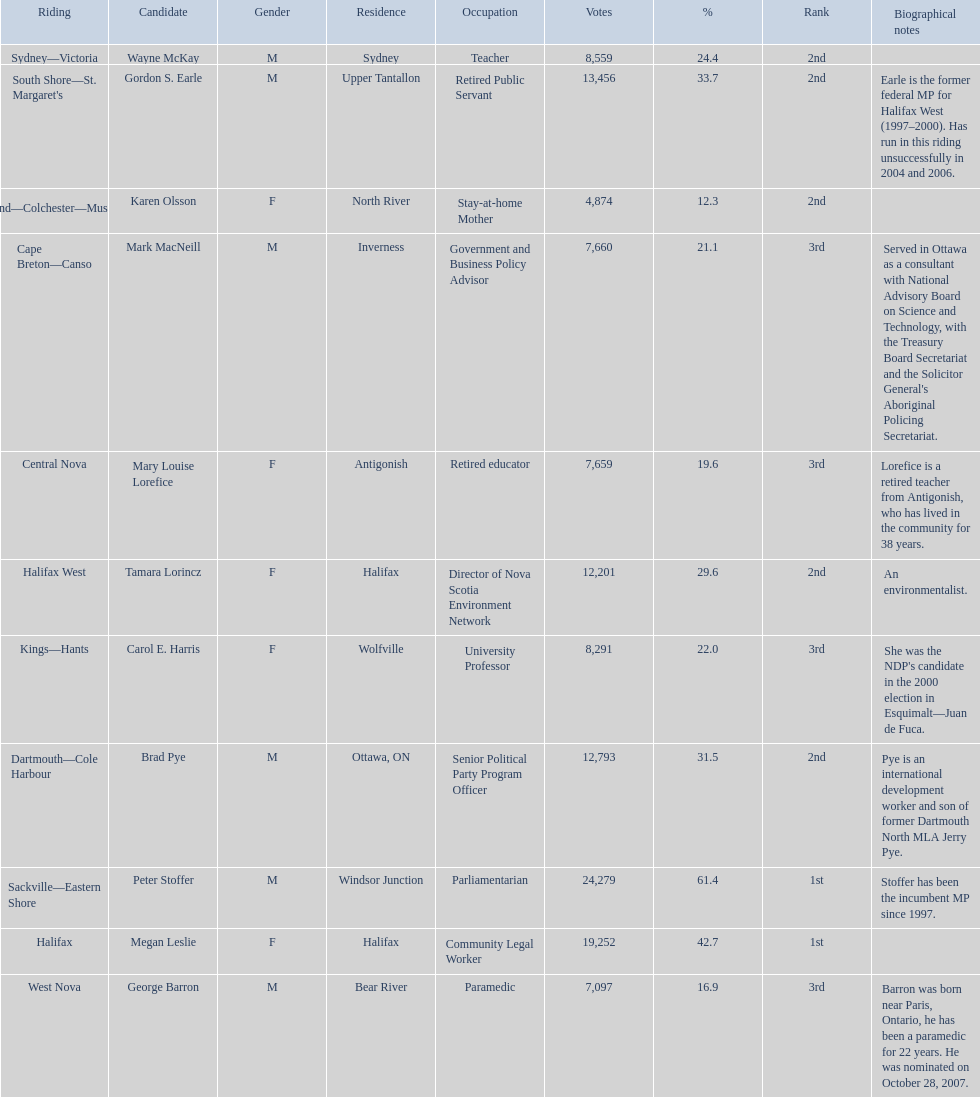How many votes did macneill receive? 7,660. How many votes did olsoon receive? 4,874. Between macneil and olsson, who received more votes? Mark MacNeill. 